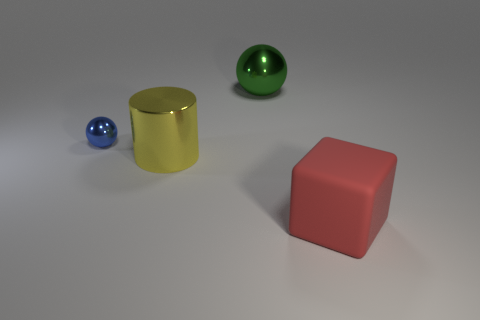Add 2 large yellow cylinders. How many objects exist? 6 Subtract all blocks. How many objects are left? 3 Subtract all big gray spheres. Subtract all metal things. How many objects are left? 1 Add 4 large green metal balls. How many large green metal balls are left? 5 Add 4 large green metal spheres. How many large green metal spheres exist? 5 Subtract 0 cyan balls. How many objects are left? 4 